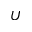Convert formula to latex. <formula><loc_0><loc_0><loc_500><loc_500>U</formula> 